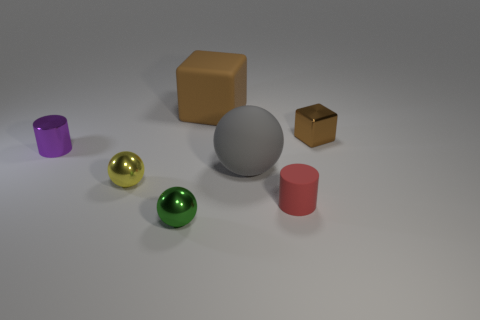There is a yellow metal thing; is its size the same as the cylinder that is to the right of the green metal thing?
Provide a short and direct response. Yes. How many large things are either gray rubber things or rubber cylinders?
Keep it short and to the point. 1. Are there more tiny balls than small green metallic objects?
Keep it short and to the point. Yes. There is a cylinder that is in front of the small metal sphere that is behind the rubber cylinder; what number of tiny objects are in front of it?
Ensure brevity in your answer.  1. What is the shape of the tiny brown metal thing?
Provide a short and direct response. Cube. What number of other things are there of the same material as the small purple cylinder
Give a very brief answer. 3. Is the red matte object the same size as the purple metallic object?
Provide a short and direct response. Yes. What shape is the brown thing on the right side of the big brown object?
Keep it short and to the point. Cube. The metal thing that is to the right of the large rubber object that is in front of the big brown thing is what color?
Offer a very short reply. Brown. There is a object in front of the red rubber cylinder; is it the same shape as the large rubber object in front of the small purple cylinder?
Your response must be concise. Yes. 